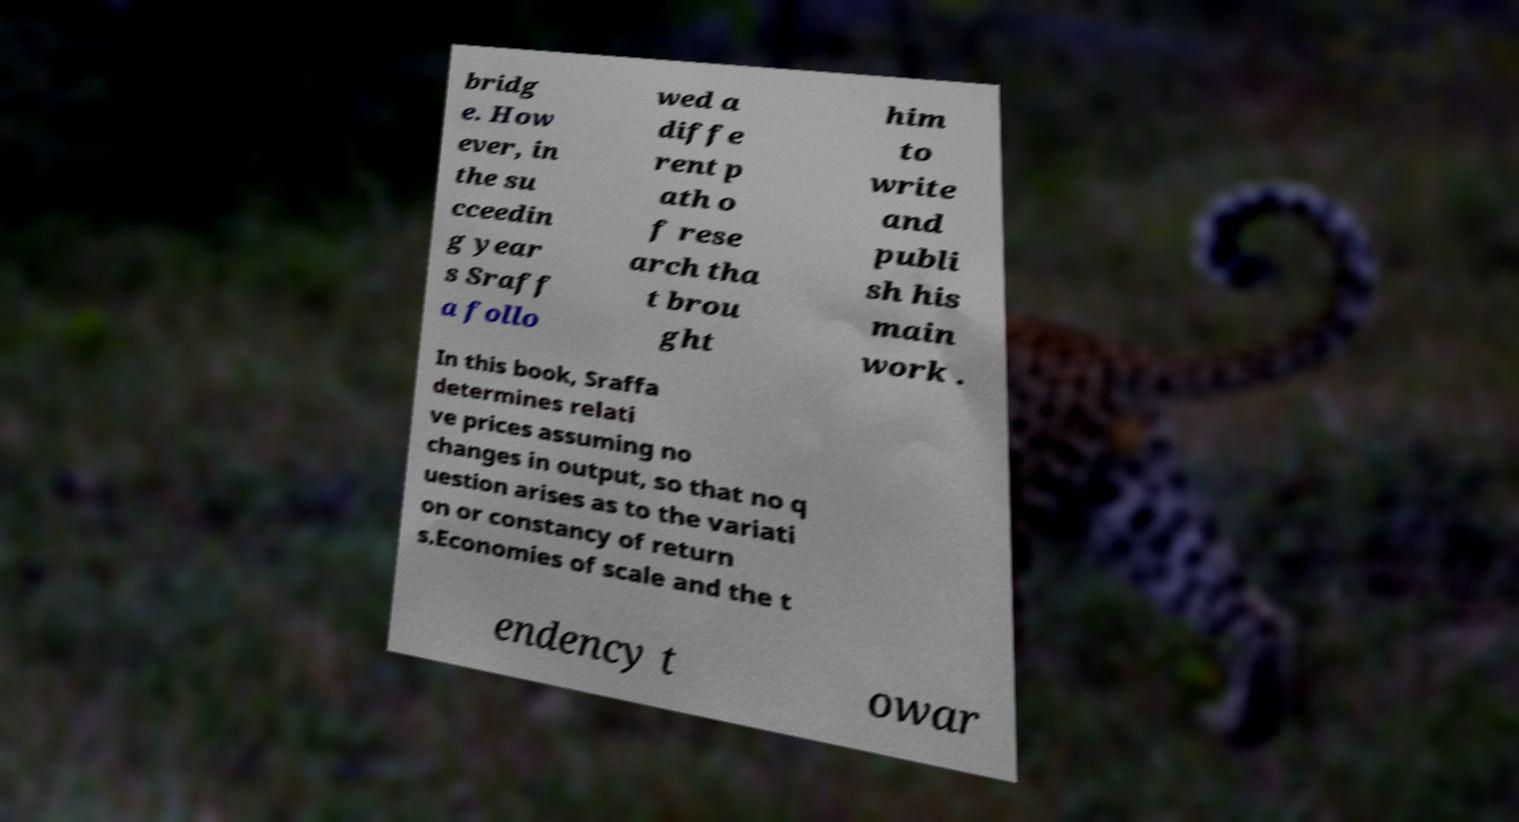I need the written content from this picture converted into text. Can you do that? bridg e. How ever, in the su cceedin g year s Sraff a follo wed a diffe rent p ath o f rese arch tha t brou ght him to write and publi sh his main work . In this book, Sraffa determines relati ve prices assuming no changes in output, so that no q uestion arises as to the variati on or constancy of return s.Economies of scale and the t endency t owar 